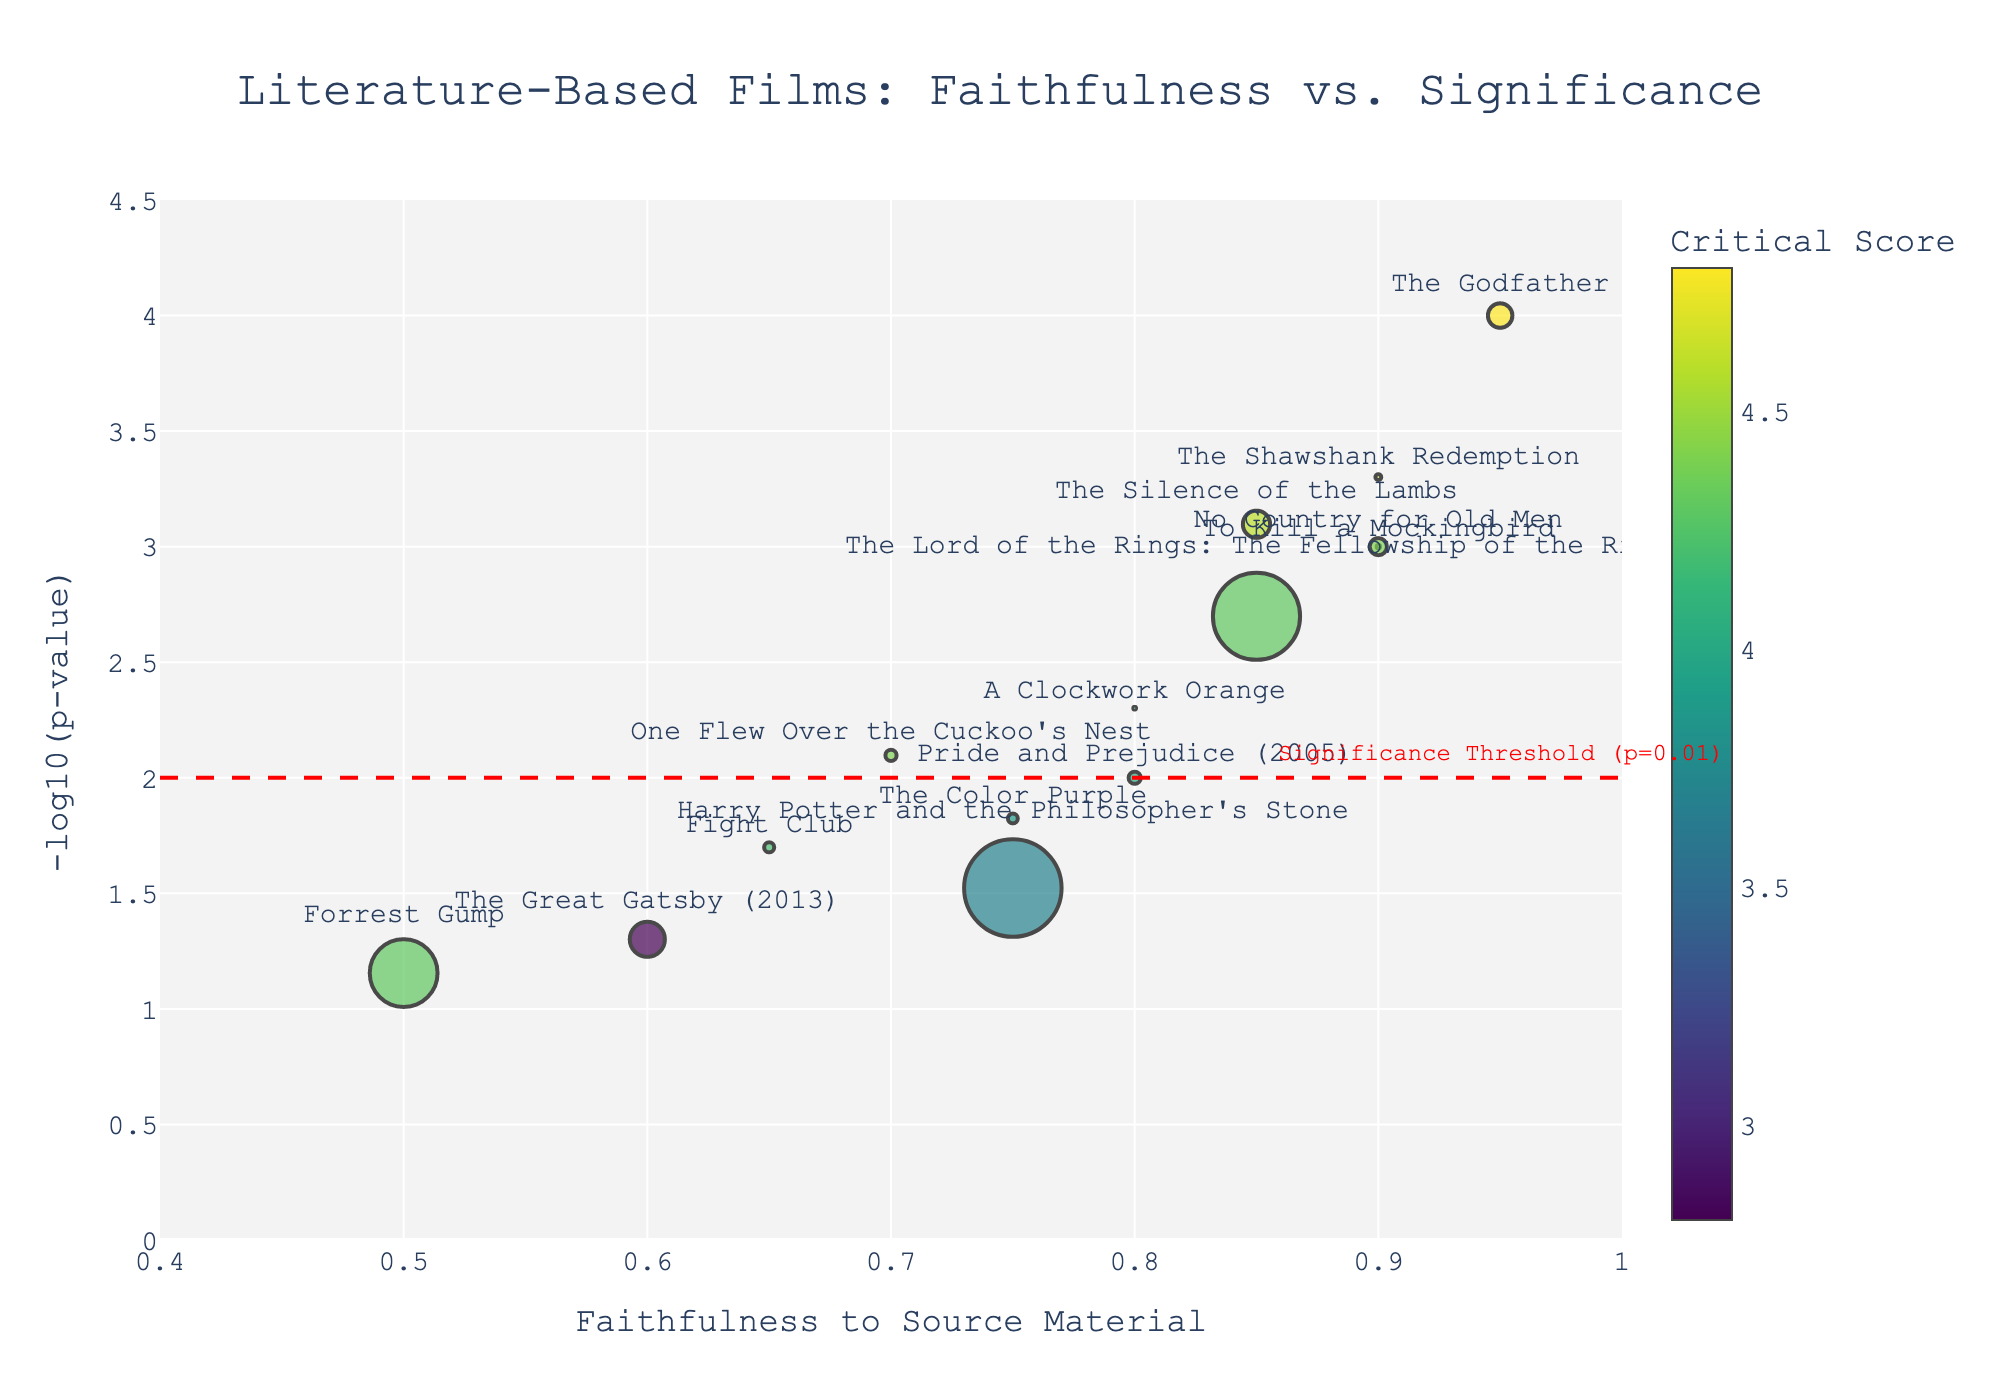What is the title of the figure? The title of the figure is usually prominently displayed at the top of the chart. In this case, the title is found in the provided code where it is set.
Answer: Literature-Based Films: Faithfulness vs. Significance What does the x-axis represent? The x-axis label indicates what is being measured. Here, it is titled 'Faithfulness to Source Material', showing how closely each film adheres to its original literary source.
Answer: Faithfulness to Source Material How many films have a p-value less than 0.01? To determine this, look at the y-axis which represents -log10(p-value). Films with a y-value higher than 2 (since -log10(0.01) = 2) have a p-value less than 0.01. Count these points on the plot.
Answer: 8 Which film has the highest faithfulness score? The film with the highest x-value on the x-axis representing 'Faithfulness Score' would have the highest faithfulness score.
Answer: The Godfather Which film has the largest box office size represented by the marker size? The largest marker on the plot represents the film with the highest box office earnings. Hover over or refer to the hovertext values to identify this film.
Answer: Harry Potter and the Philosopher's Stone What is the critical score of 'The Shawshank Redemption'? Check the hover information for 'The Shawshank Redemption' to find its critical score.
Answer: 4.7 Which film is positioned closest to the significance threshold line at y = 2? Identify the point closest to y = 2 by eye-balling the proximity of the markers to this horizontal dashed line.
Answer: One Flew Over the Cuckoo's Nest How does the critical score correlate with the faithfulness score for these films? Observe and interpret if there is any visual trend or clustering between the 'Faithfulness Score' and 'Critical Score', as represented by the color gradient of the markers.
Answer: Generally positive correlation Which film has a high faithfulness score but a relatively low box office? Find a film that is positioned towards the high end of the x-axis (faithfulness), but with a smaller-sized marker, indicating lower box office earnings.
Answer: To Kill a Mockingbird How many films surpass the critical score of 4.5? Check the color gradient and hover information for markers that have a critical score greater than 4.5.
Answer: 4 